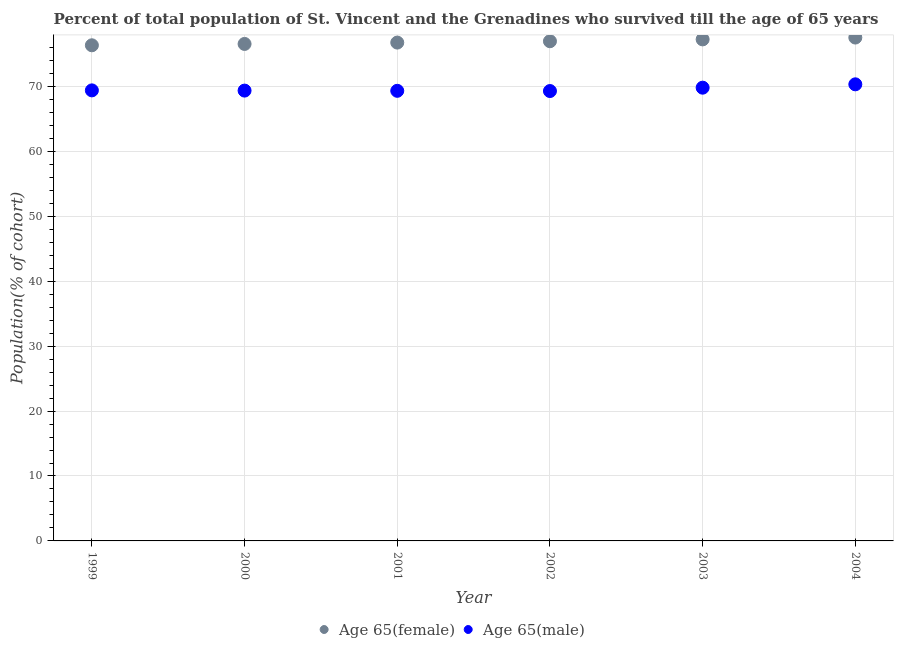How many different coloured dotlines are there?
Provide a succinct answer. 2. Is the number of dotlines equal to the number of legend labels?
Offer a very short reply. Yes. What is the percentage of male population who survived till age of 65 in 2000?
Your answer should be compact. 69.36. Across all years, what is the maximum percentage of female population who survived till age of 65?
Provide a short and direct response. 77.53. Across all years, what is the minimum percentage of male population who survived till age of 65?
Make the answer very short. 69.29. In which year was the percentage of male population who survived till age of 65 minimum?
Your answer should be very brief. 2002. What is the total percentage of male population who survived till age of 65 in the graph?
Your response must be concise. 417.5. What is the difference between the percentage of male population who survived till age of 65 in 1999 and that in 2001?
Make the answer very short. 0.07. What is the difference between the percentage of female population who survived till age of 65 in 1999 and the percentage of male population who survived till age of 65 in 2004?
Ensure brevity in your answer.  6.01. What is the average percentage of female population who survived till age of 65 per year?
Your answer should be very brief. 76.9. In the year 2004, what is the difference between the percentage of male population who survived till age of 65 and percentage of female population who survived till age of 65?
Your response must be concise. -7.2. In how many years, is the percentage of female population who survived till age of 65 greater than 26 %?
Keep it short and to the point. 6. What is the ratio of the percentage of male population who survived till age of 65 in 2003 to that in 2004?
Offer a terse response. 0.99. Is the difference between the percentage of female population who survived till age of 65 in 1999 and 2004 greater than the difference between the percentage of male population who survived till age of 65 in 1999 and 2004?
Your response must be concise. No. What is the difference between the highest and the second highest percentage of female population who survived till age of 65?
Offer a very short reply. 0.28. What is the difference between the highest and the lowest percentage of female population who survived till age of 65?
Ensure brevity in your answer.  1.19. In how many years, is the percentage of male population who survived till age of 65 greater than the average percentage of male population who survived till age of 65 taken over all years?
Your answer should be compact. 2. Is the percentage of male population who survived till age of 65 strictly less than the percentage of female population who survived till age of 65 over the years?
Provide a succinct answer. Yes. How many dotlines are there?
Keep it short and to the point. 2. Are the values on the major ticks of Y-axis written in scientific E-notation?
Offer a terse response. No. How many legend labels are there?
Give a very brief answer. 2. How are the legend labels stacked?
Provide a succinct answer. Horizontal. What is the title of the graph?
Ensure brevity in your answer.  Percent of total population of St. Vincent and the Grenadines who survived till the age of 65 years. What is the label or title of the Y-axis?
Your answer should be compact. Population(% of cohort). What is the Population(% of cohort) of Age 65(female) in 1999?
Make the answer very short. 76.34. What is the Population(% of cohort) in Age 65(male) in 1999?
Ensure brevity in your answer.  69.39. What is the Population(% of cohort) in Age 65(female) in 2000?
Make the answer very short. 76.55. What is the Population(% of cohort) of Age 65(male) in 2000?
Offer a very short reply. 69.36. What is the Population(% of cohort) of Age 65(female) in 2001?
Your answer should be compact. 76.75. What is the Population(% of cohort) of Age 65(male) in 2001?
Offer a very short reply. 69.33. What is the Population(% of cohort) in Age 65(female) in 2002?
Your response must be concise. 76.96. What is the Population(% of cohort) in Age 65(male) in 2002?
Your answer should be compact. 69.29. What is the Population(% of cohort) in Age 65(female) in 2003?
Offer a terse response. 77.25. What is the Population(% of cohort) in Age 65(male) in 2003?
Offer a very short reply. 69.81. What is the Population(% of cohort) in Age 65(female) in 2004?
Offer a very short reply. 77.53. What is the Population(% of cohort) of Age 65(male) in 2004?
Ensure brevity in your answer.  70.32. Across all years, what is the maximum Population(% of cohort) in Age 65(female)?
Offer a terse response. 77.53. Across all years, what is the maximum Population(% of cohort) in Age 65(male)?
Give a very brief answer. 70.32. Across all years, what is the minimum Population(% of cohort) in Age 65(female)?
Your answer should be compact. 76.34. Across all years, what is the minimum Population(% of cohort) of Age 65(male)?
Provide a short and direct response. 69.29. What is the total Population(% of cohort) of Age 65(female) in the graph?
Keep it short and to the point. 461.37. What is the total Population(% of cohort) of Age 65(male) in the graph?
Your answer should be compact. 417.5. What is the difference between the Population(% of cohort) of Age 65(female) in 1999 and that in 2000?
Your answer should be compact. -0.21. What is the difference between the Population(% of cohort) in Age 65(male) in 1999 and that in 2000?
Your response must be concise. 0.03. What is the difference between the Population(% of cohort) of Age 65(female) in 1999 and that in 2001?
Your answer should be very brief. -0.42. What is the difference between the Population(% of cohort) of Age 65(male) in 1999 and that in 2001?
Make the answer very short. 0.07. What is the difference between the Population(% of cohort) in Age 65(female) in 1999 and that in 2002?
Keep it short and to the point. -0.63. What is the difference between the Population(% of cohort) of Age 65(male) in 1999 and that in 2002?
Make the answer very short. 0.1. What is the difference between the Population(% of cohort) in Age 65(female) in 1999 and that in 2003?
Make the answer very short. -0.91. What is the difference between the Population(% of cohort) in Age 65(male) in 1999 and that in 2003?
Your answer should be compact. -0.42. What is the difference between the Population(% of cohort) of Age 65(female) in 1999 and that in 2004?
Offer a terse response. -1.19. What is the difference between the Population(% of cohort) of Age 65(male) in 1999 and that in 2004?
Make the answer very short. -0.93. What is the difference between the Population(% of cohort) in Age 65(female) in 2000 and that in 2001?
Your answer should be very brief. -0.21. What is the difference between the Population(% of cohort) of Age 65(male) in 2000 and that in 2001?
Offer a very short reply. 0.03. What is the difference between the Population(% of cohort) in Age 65(female) in 2000 and that in 2002?
Your answer should be very brief. -0.42. What is the difference between the Population(% of cohort) of Age 65(male) in 2000 and that in 2002?
Your response must be concise. 0.07. What is the difference between the Population(% of cohort) of Age 65(female) in 2000 and that in 2003?
Ensure brevity in your answer.  -0.7. What is the difference between the Population(% of cohort) in Age 65(male) in 2000 and that in 2003?
Offer a terse response. -0.45. What is the difference between the Population(% of cohort) of Age 65(female) in 2000 and that in 2004?
Offer a terse response. -0.98. What is the difference between the Population(% of cohort) of Age 65(male) in 2000 and that in 2004?
Provide a succinct answer. -0.97. What is the difference between the Population(% of cohort) of Age 65(female) in 2001 and that in 2002?
Provide a short and direct response. -0.21. What is the difference between the Population(% of cohort) in Age 65(male) in 2001 and that in 2002?
Give a very brief answer. 0.03. What is the difference between the Population(% of cohort) of Age 65(female) in 2001 and that in 2003?
Offer a terse response. -0.49. What is the difference between the Population(% of cohort) in Age 65(male) in 2001 and that in 2003?
Give a very brief answer. -0.48. What is the difference between the Population(% of cohort) in Age 65(female) in 2001 and that in 2004?
Offer a very short reply. -0.78. What is the difference between the Population(% of cohort) of Age 65(male) in 2001 and that in 2004?
Make the answer very short. -1. What is the difference between the Population(% of cohort) of Age 65(female) in 2002 and that in 2003?
Your response must be concise. -0.28. What is the difference between the Population(% of cohort) in Age 65(male) in 2002 and that in 2003?
Your response must be concise. -0.52. What is the difference between the Population(% of cohort) of Age 65(female) in 2002 and that in 2004?
Your response must be concise. -0.57. What is the difference between the Population(% of cohort) in Age 65(male) in 2002 and that in 2004?
Ensure brevity in your answer.  -1.03. What is the difference between the Population(% of cohort) in Age 65(female) in 2003 and that in 2004?
Provide a succinct answer. -0.28. What is the difference between the Population(% of cohort) of Age 65(male) in 2003 and that in 2004?
Your answer should be very brief. -0.52. What is the difference between the Population(% of cohort) of Age 65(female) in 1999 and the Population(% of cohort) of Age 65(male) in 2000?
Your answer should be compact. 6.98. What is the difference between the Population(% of cohort) in Age 65(female) in 1999 and the Population(% of cohort) in Age 65(male) in 2001?
Keep it short and to the point. 7.01. What is the difference between the Population(% of cohort) in Age 65(female) in 1999 and the Population(% of cohort) in Age 65(male) in 2002?
Your response must be concise. 7.05. What is the difference between the Population(% of cohort) in Age 65(female) in 1999 and the Population(% of cohort) in Age 65(male) in 2003?
Provide a short and direct response. 6.53. What is the difference between the Population(% of cohort) of Age 65(female) in 1999 and the Population(% of cohort) of Age 65(male) in 2004?
Your answer should be compact. 6.01. What is the difference between the Population(% of cohort) in Age 65(female) in 2000 and the Population(% of cohort) in Age 65(male) in 2001?
Provide a short and direct response. 7.22. What is the difference between the Population(% of cohort) in Age 65(female) in 2000 and the Population(% of cohort) in Age 65(male) in 2002?
Give a very brief answer. 7.25. What is the difference between the Population(% of cohort) of Age 65(female) in 2000 and the Population(% of cohort) of Age 65(male) in 2003?
Give a very brief answer. 6.74. What is the difference between the Population(% of cohort) in Age 65(female) in 2000 and the Population(% of cohort) in Age 65(male) in 2004?
Give a very brief answer. 6.22. What is the difference between the Population(% of cohort) of Age 65(female) in 2001 and the Population(% of cohort) of Age 65(male) in 2002?
Make the answer very short. 7.46. What is the difference between the Population(% of cohort) of Age 65(female) in 2001 and the Population(% of cohort) of Age 65(male) in 2003?
Provide a short and direct response. 6.95. What is the difference between the Population(% of cohort) of Age 65(female) in 2001 and the Population(% of cohort) of Age 65(male) in 2004?
Ensure brevity in your answer.  6.43. What is the difference between the Population(% of cohort) in Age 65(female) in 2002 and the Population(% of cohort) in Age 65(male) in 2003?
Offer a very short reply. 7.15. What is the difference between the Population(% of cohort) of Age 65(female) in 2002 and the Population(% of cohort) of Age 65(male) in 2004?
Keep it short and to the point. 6.64. What is the difference between the Population(% of cohort) in Age 65(female) in 2003 and the Population(% of cohort) in Age 65(male) in 2004?
Make the answer very short. 6.92. What is the average Population(% of cohort) of Age 65(female) per year?
Give a very brief answer. 76.9. What is the average Population(% of cohort) in Age 65(male) per year?
Offer a terse response. 69.58. In the year 1999, what is the difference between the Population(% of cohort) of Age 65(female) and Population(% of cohort) of Age 65(male)?
Offer a terse response. 6.94. In the year 2000, what is the difference between the Population(% of cohort) of Age 65(female) and Population(% of cohort) of Age 65(male)?
Your answer should be compact. 7.19. In the year 2001, what is the difference between the Population(% of cohort) in Age 65(female) and Population(% of cohort) in Age 65(male)?
Keep it short and to the point. 7.43. In the year 2002, what is the difference between the Population(% of cohort) of Age 65(female) and Population(% of cohort) of Age 65(male)?
Keep it short and to the point. 7.67. In the year 2003, what is the difference between the Population(% of cohort) of Age 65(female) and Population(% of cohort) of Age 65(male)?
Ensure brevity in your answer.  7.44. In the year 2004, what is the difference between the Population(% of cohort) of Age 65(female) and Population(% of cohort) of Age 65(male)?
Offer a very short reply. 7.2. What is the ratio of the Population(% of cohort) of Age 65(female) in 1999 to that in 2000?
Make the answer very short. 1. What is the ratio of the Population(% of cohort) in Age 65(male) in 1999 to that in 2000?
Make the answer very short. 1. What is the ratio of the Population(% of cohort) of Age 65(female) in 1999 to that in 2001?
Your response must be concise. 0.99. What is the ratio of the Population(% of cohort) of Age 65(female) in 1999 to that in 2002?
Make the answer very short. 0.99. What is the ratio of the Population(% of cohort) in Age 65(male) in 1999 to that in 2002?
Keep it short and to the point. 1. What is the ratio of the Population(% of cohort) of Age 65(female) in 1999 to that in 2004?
Keep it short and to the point. 0.98. What is the ratio of the Population(% of cohort) in Age 65(male) in 1999 to that in 2004?
Offer a very short reply. 0.99. What is the ratio of the Population(% of cohort) of Age 65(male) in 2000 to that in 2001?
Provide a short and direct response. 1. What is the ratio of the Population(% of cohort) in Age 65(female) in 2000 to that in 2003?
Your answer should be very brief. 0.99. What is the ratio of the Population(% of cohort) in Age 65(female) in 2000 to that in 2004?
Your answer should be very brief. 0.99. What is the ratio of the Population(% of cohort) in Age 65(male) in 2000 to that in 2004?
Keep it short and to the point. 0.99. What is the ratio of the Population(% of cohort) of Age 65(male) in 2001 to that in 2002?
Your answer should be very brief. 1. What is the ratio of the Population(% of cohort) of Age 65(male) in 2001 to that in 2004?
Make the answer very short. 0.99. What is the ratio of the Population(% of cohort) of Age 65(female) in 2003 to that in 2004?
Ensure brevity in your answer.  1. What is the ratio of the Population(% of cohort) in Age 65(male) in 2003 to that in 2004?
Provide a short and direct response. 0.99. What is the difference between the highest and the second highest Population(% of cohort) in Age 65(female)?
Ensure brevity in your answer.  0.28. What is the difference between the highest and the second highest Population(% of cohort) in Age 65(male)?
Offer a very short reply. 0.52. What is the difference between the highest and the lowest Population(% of cohort) in Age 65(female)?
Your response must be concise. 1.19. What is the difference between the highest and the lowest Population(% of cohort) of Age 65(male)?
Keep it short and to the point. 1.03. 